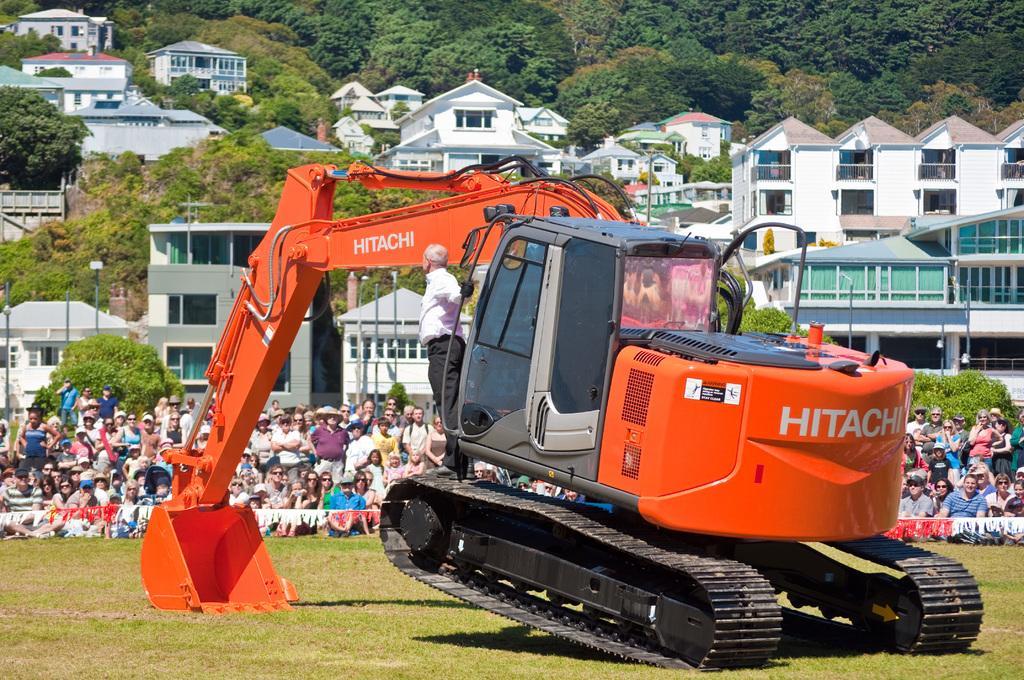How would you summarize this image in a sentence or two? In this picture there is a man who is standing on the bulldozer. In the back I can see the audience were watching the show. In the background I can see many trees and buildings. On the left I can see some street lights and poles near to the tree. 